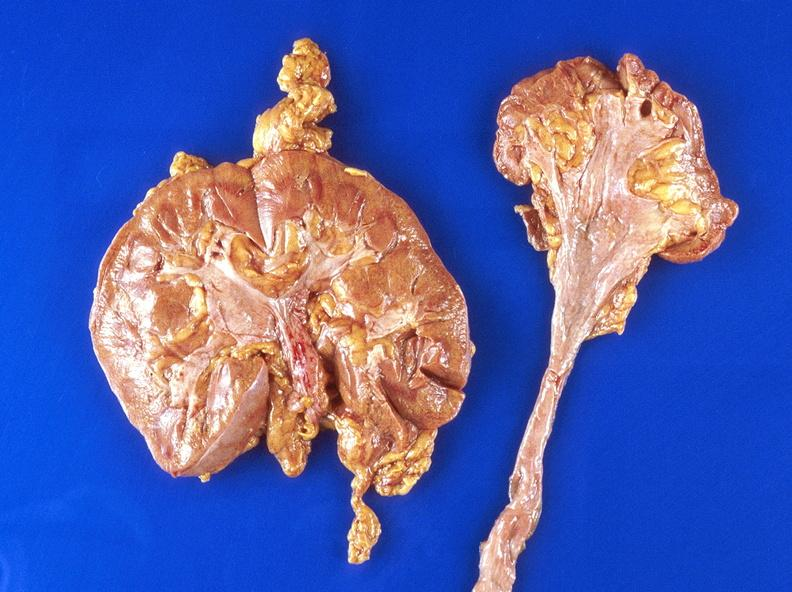does source show hydronephrosis?
Answer the question using a single word or phrase. No 